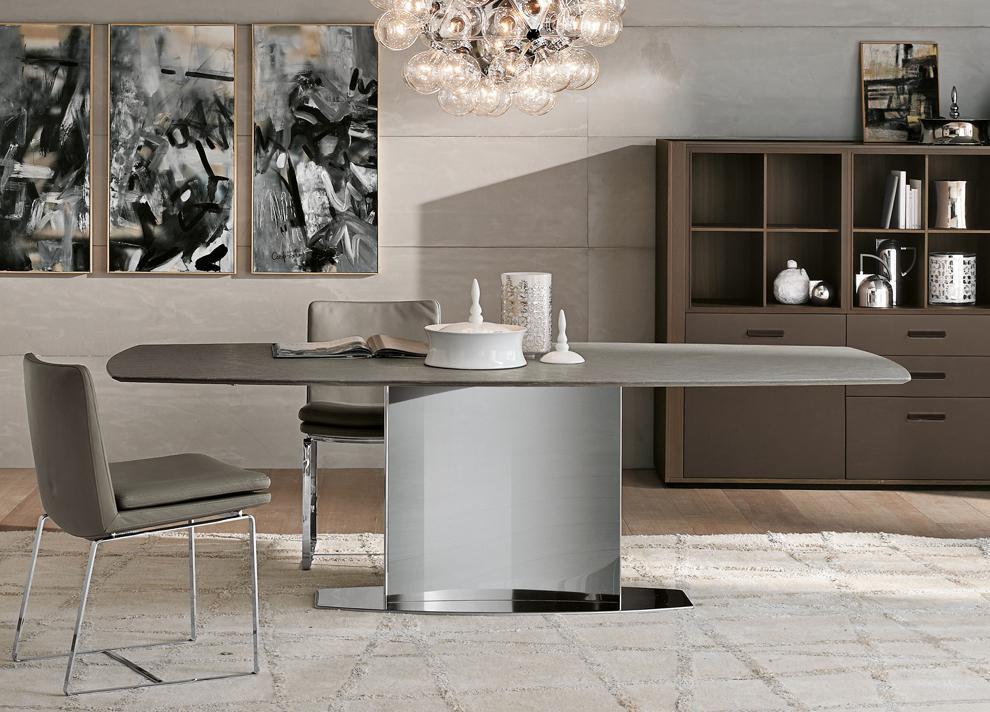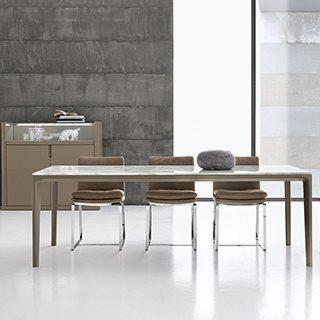The first image is the image on the left, the second image is the image on the right. For the images shown, is this caption "In one image, three armchairs are positioned by a square table." true? Answer yes or no. No. 